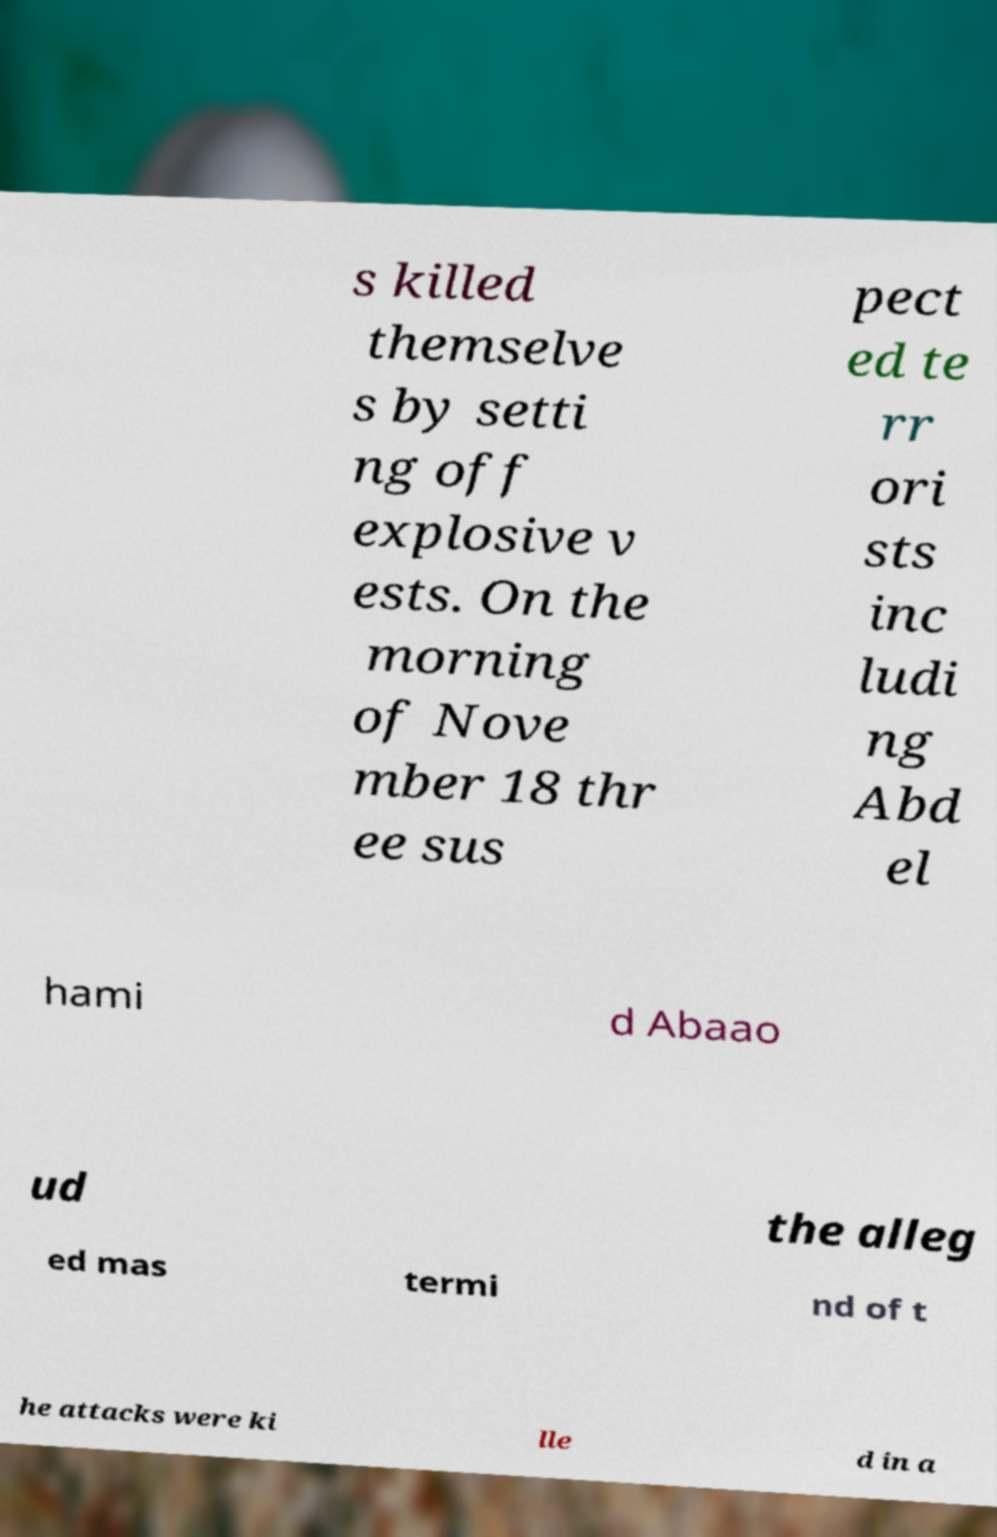Please read and relay the text visible in this image. What does it say? s killed themselve s by setti ng off explosive v ests. On the morning of Nove mber 18 thr ee sus pect ed te rr ori sts inc ludi ng Abd el hami d Abaao ud the alleg ed mas termi nd of t he attacks were ki lle d in a 